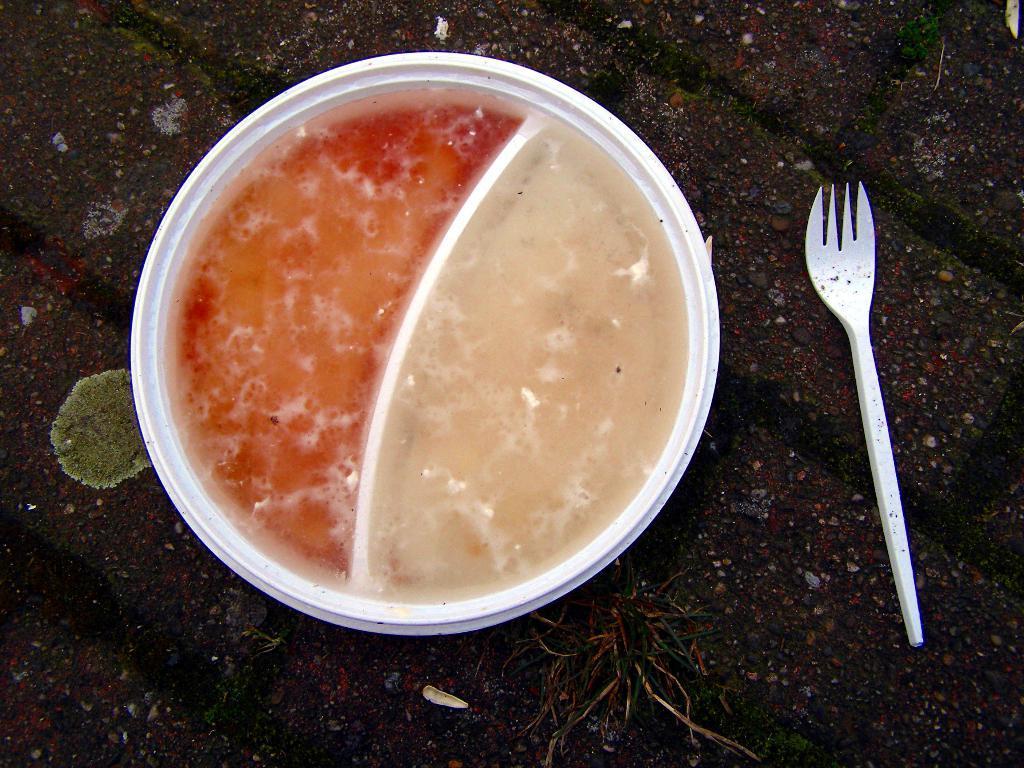Describe this image in one or two sentences. There is a bowl which is consisting of two types of food items. One is red colour and other one is white colour. There is a fork beside the bowl. The bowl and the fork are placed on the floor which is made up of blocks. 